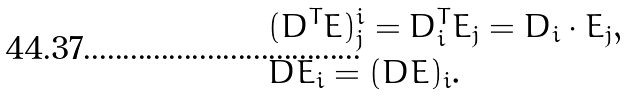<formula> <loc_0><loc_0><loc_500><loc_500>& ( D ^ { T } E ) ^ { i } _ { j } = D _ { i } ^ { T } E _ { j } = D _ { i } \cdot E _ { j } , \\ & D E _ { i } = ( D E ) _ { i } .</formula> 